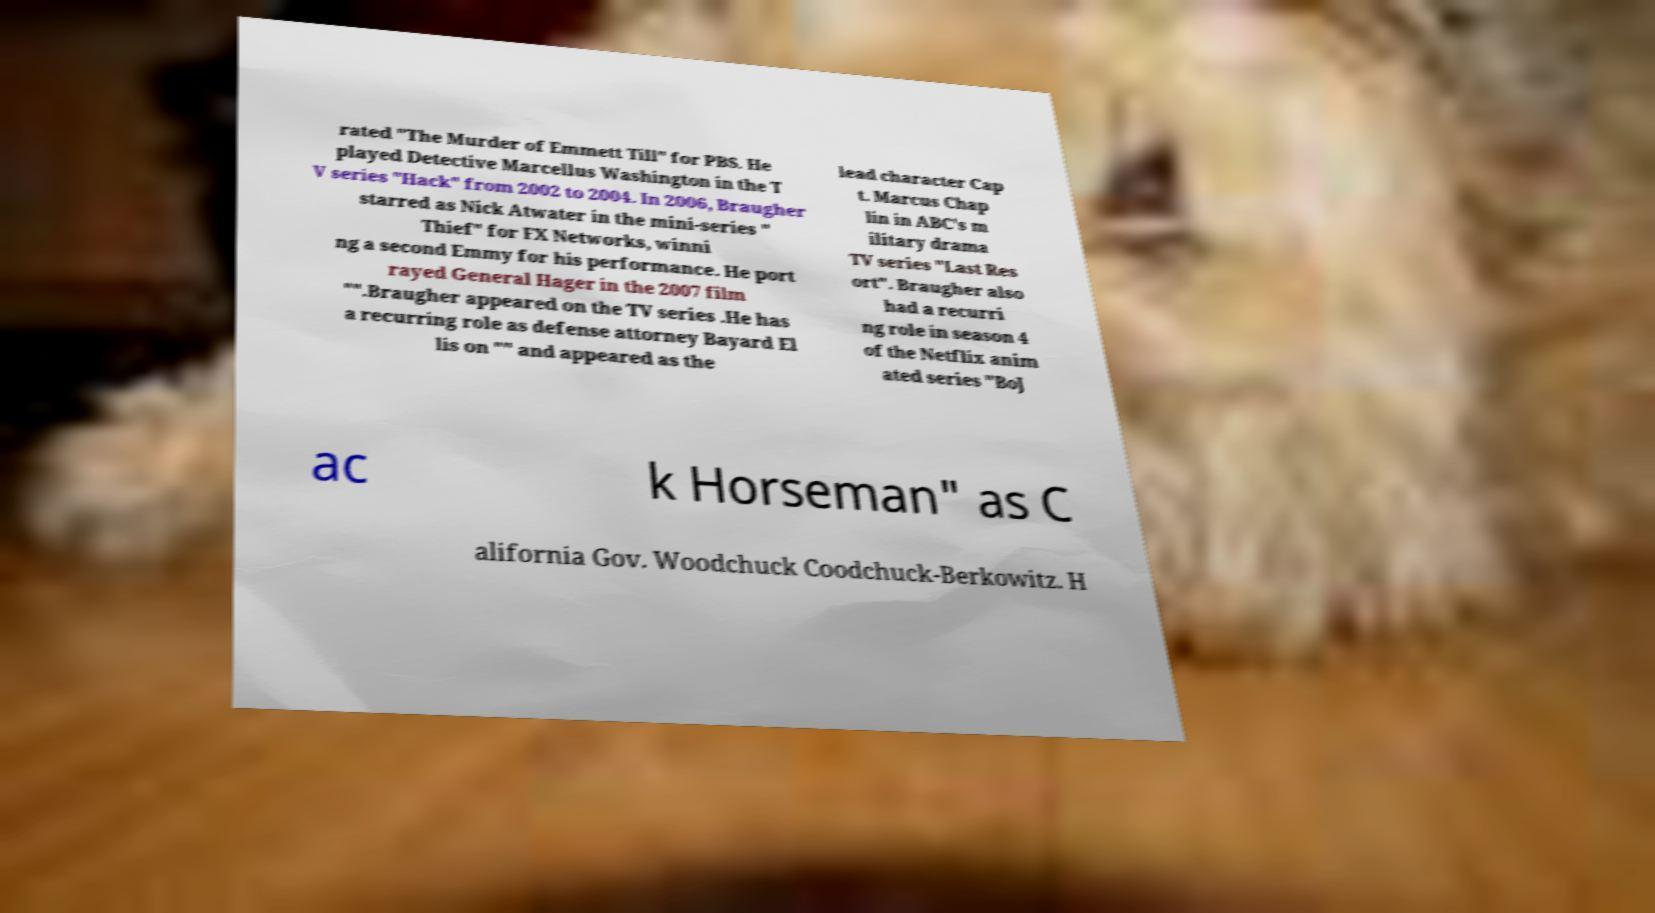Please identify and transcribe the text found in this image. rated "The Murder of Emmett Till" for PBS. He played Detective Marcellus Washington in the T V series "Hack" from 2002 to 2004. In 2006, Braugher starred as Nick Atwater in the mini-series " Thief" for FX Networks, winni ng a second Emmy for his performance. He port rayed General Hager in the 2007 film "".Braugher appeared on the TV series .He has a recurring role as defense attorney Bayard El lis on "" and appeared as the lead character Cap t. Marcus Chap lin in ABC's m ilitary drama TV series "Last Res ort". Braugher also had a recurri ng role in season 4 of the Netflix anim ated series "BoJ ac k Horseman" as C alifornia Gov. Woodchuck Coodchuck-Berkowitz. H 